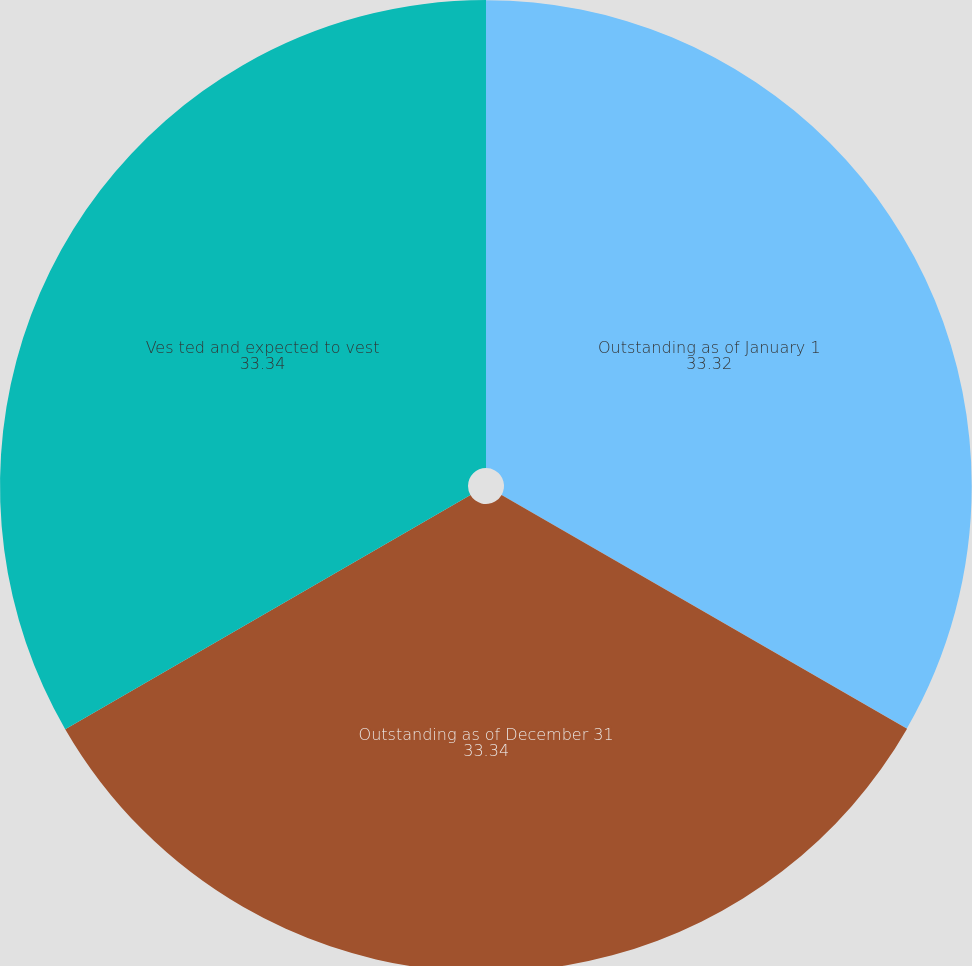<chart> <loc_0><loc_0><loc_500><loc_500><pie_chart><fcel>Outstanding as of January 1<fcel>Outstanding as of December 31<fcel>Ves ted and expected to vest<nl><fcel>33.32%<fcel>33.34%<fcel>33.34%<nl></chart> 